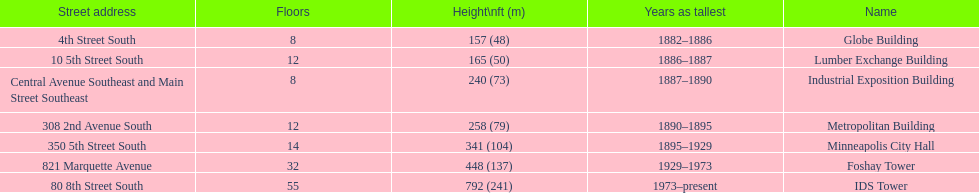Which building has the same number of floors as the lumber exchange building? Metropolitan Building. 